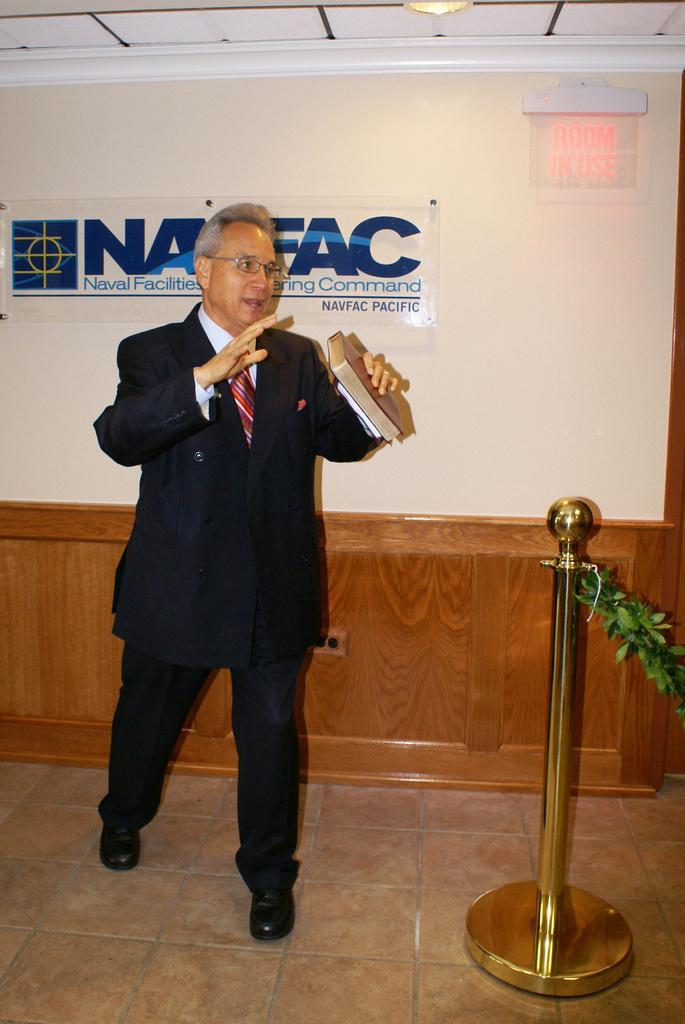Can you describe this image briefly? In the image we can see a man walking, wearing clothes, spectacles and he is holding a book in his hand. Here we can see poll, leaves, floor, wall and the poster. Here we can see the light. 